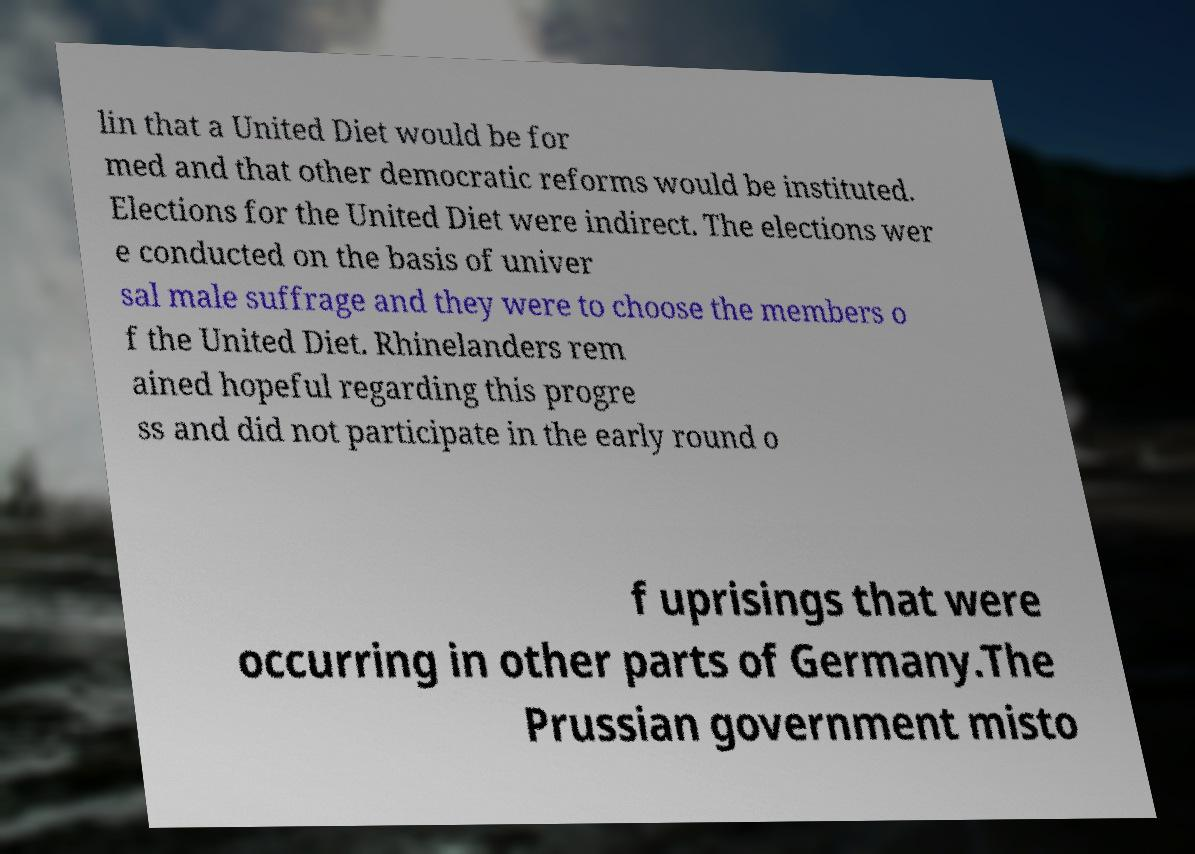What messages or text are displayed in this image? I need them in a readable, typed format. lin that a United Diet would be for med and that other democratic reforms would be instituted. Elections for the United Diet were indirect. The elections wer e conducted on the basis of univer sal male suffrage and they were to choose the members o f the United Diet. Rhinelanders rem ained hopeful regarding this progre ss and did not participate in the early round o f uprisings that were occurring in other parts of Germany.The Prussian government misto 